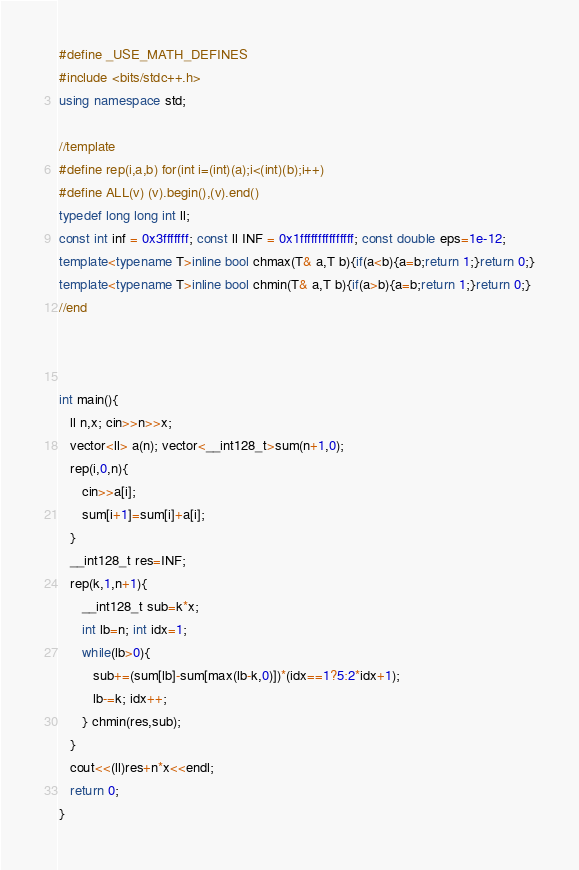Convert code to text. <code><loc_0><loc_0><loc_500><loc_500><_C++_>#define _USE_MATH_DEFINES
#include <bits/stdc++.h>
using namespace std;

//template
#define rep(i,a,b) for(int i=(int)(a);i<(int)(b);i++)
#define ALL(v) (v).begin(),(v).end()
typedef long long int ll;
const int inf = 0x3fffffff; const ll INF = 0x1fffffffffffffff; const double eps=1e-12;
template<typename T>inline bool chmax(T& a,T b){if(a<b){a=b;return 1;}return 0;}
template<typename T>inline bool chmin(T& a,T b){if(a>b){a=b;return 1;}return 0;}
//end



int main(){
   ll n,x; cin>>n>>x;
   vector<ll> a(n); vector<__int128_t>sum(n+1,0);
   rep(i,0,n){
      cin>>a[i];
      sum[i+1]=sum[i]+a[i];
   }
   __int128_t res=INF;
   rep(k,1,n+1){
      __int128_t sub=k*x;
      int lb=n; int idx=1;
      while(lb>0){
         sub+=(sum[lb]-sum[max(lb-k,0)])*(idx==1?5:2*idx+1);
         lb-=k; idx++;
      } chmin(res,sub);
   }
   cout<<(ll)res+n*x<<endl;
   return 0;
}</code> 